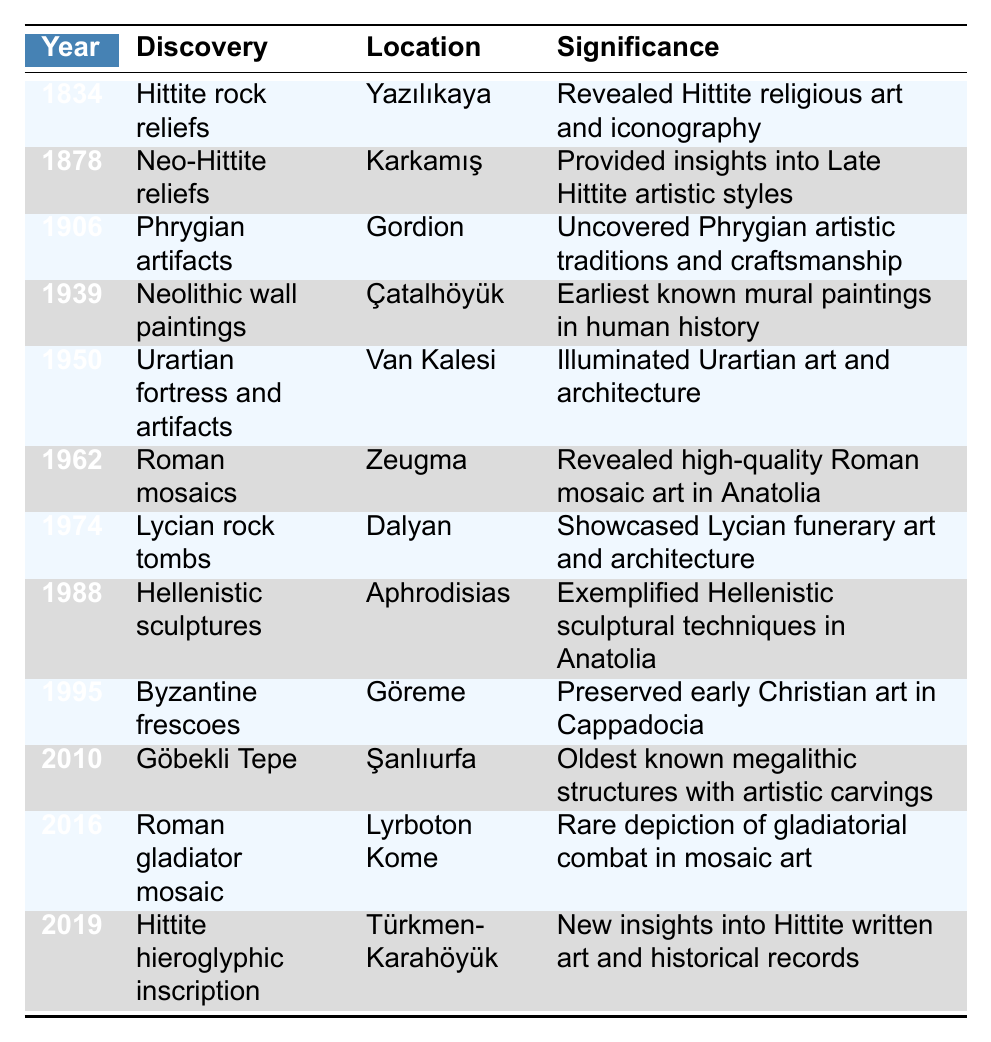What year were the Hittite rock reliefs discovered? The table indicates that the Hittite rock reliefs were discovered in 1834.
Answer: 1834 Which location is associated with the discovery of Roman mosaics? According to the table, Roman mosaics were discovered in Zeugma.
Answer: Zeugma What is the significance of the Urartian fortress and artifacts found in 1950? The table states that this discovery illuminated Urartian art and architecture.
Answer: Illuminated Urartian art and architecture How many discoveries were made before 1970? To find this, count the number of discoveries listed before the year 1970: 1 (1834) + 1 (1878) + 1 (1906) + 1 (1939) + 1 (1950) + 1 (1962) = 6.
Answer: 6 Did any discoveries occur in the 21st century? Yes, the table shows that there were discoveries in 2010 and 2016, which are both in the 21st century.
Answer: Yes What discovery in 2010 is noted for having the oldest known megalithic structures? The discovery in 2010 mentioned is Göbekli Tepe, known for the oldest known megalithic structures with artistic carvings.
Answer: Göbekli Tepe Which discovery has the latest year listed in the table? The latest discovery mentioned in the table is the Hittite hieroglyphic inscription from 2019.
Answer: 2019 What significance is associated with the Neolithic wall paintings in Çatalhöyük? The significance listed states that these wall paintings are the earliest known mural paintings in human history.
Answer: Earliest known mural paintings in human history In which year were Hellenistic sculptures discovered, and what was their significance? The table indicates that Hellenistic sculptures were discovered in 1988 and exemplified Hellenistic sculptural techniques in Anatolia.
Answer: 1988; Exemplified Hellenistic sculptural techniques in Anatolia How many discoveries are noted to have occurred after 2000? The discoveries listed after 2000 are for the years 2010, 2016, and 2019. Counting these gives us 3 discoveries.
Answer: 3 Which discovery provided insights into Late Hittite artistic styles, and in what year did it occur? The Neo-Hittite reliefs provided insights into Late Hittite artistic styles, and this occurred in 1878.
Answer: Neo-Hittite reliefs, 1878 